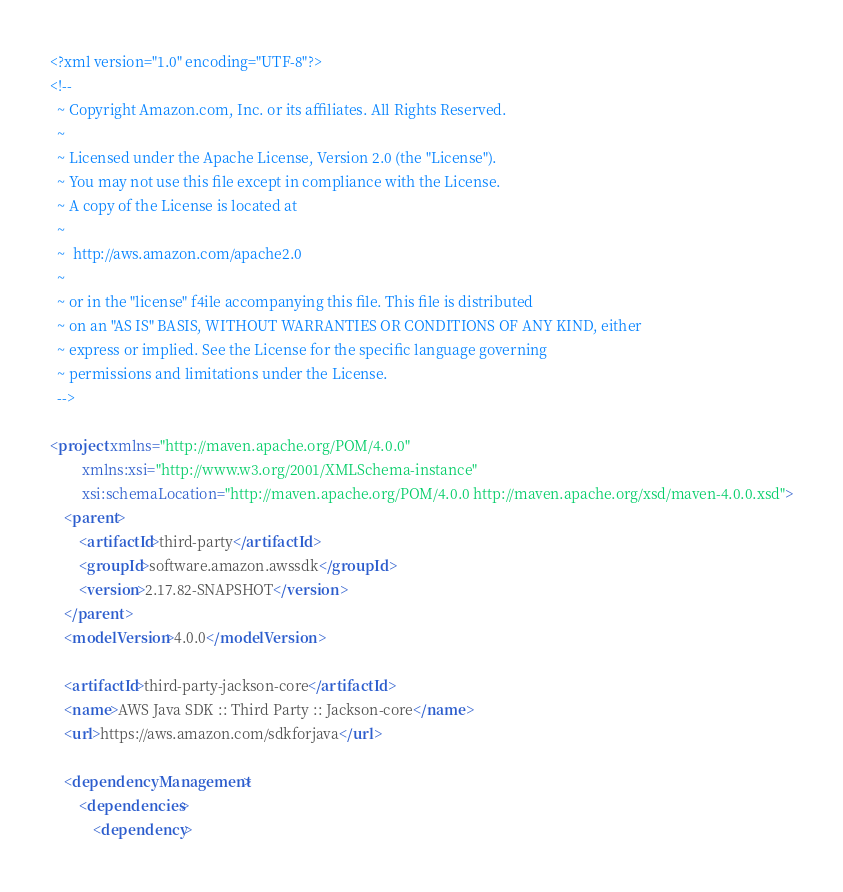Convert code to text. <code><loc_0><loc_0><loc_500><loc_500><_XML_><?xml version="1.0" encoding="UTF-8"?>
<!--
  ~ Copyright Amazon.com, Inc. or its affiliates. All Rights Reserved.
  ~
  ~ Licensed under the Apache License, Version 2.0 (the "License").
  ~ You may not use this file except in compliance with the License.
  ~ A copy of the License is located at
  ~
  ~  http://aws.amazon.com/apache2.0
  ~
  ~ or in the "license" f4ile accompanying this file. This file is distributed
  ~ on an "AS IS" BASIS, WITHOUT WARRANTIES OR CONDITIONS OF ANY KIND, either
  ~ express or implied. See the License for the specific language governing
  ~ permissions and limitations under the License.
  -->

<project xmlns="http://maven.apache.org/POM/4.0.0"
         xmlns:xsi="http://www.w3.org/2001/XMLSchema-instance"
         xsi:schemaLocation="http://maven.apache.org/POM/4.0.0 http://maven.apache.org/xsd/maven-4.0.0.xsd">
    <parent>
        <artifactId>third-party</artifactId>
        <groupId>software.amazon.awssdk</groupId>
        <version>2.17.82-SNAPSHOT</version>
    </parent>
    <modelVersion>4.0.0</modelVersion>

    <artifactId>third-party-jackson-core</artifactId>
    <name>AWS Java SDK :: Third Party :: Jackson-core</name>
    <url>https://aws.amazon.com/sdkforjava</url>

    <dependencyManagement>
        <dependencies>
            <dependency></code> 